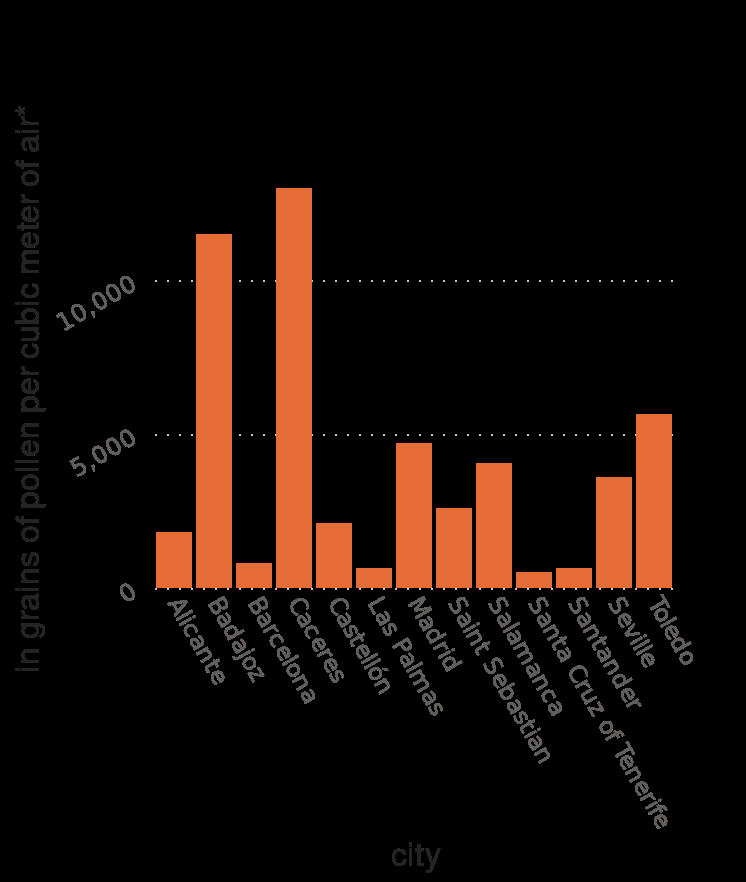<image>
Which year's data does the bar plot represent? The bar plot represents the pollen count in selected cities during spring in Spain in 2017. What does the x-axis measure in the bar plot? The x-axis measures city on a categorical scale. 